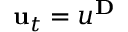Convert formula to latex. <formula><loc_0><loc_0><loc_500><loc_500>u _ { t } = u ^ { D }</formula> 